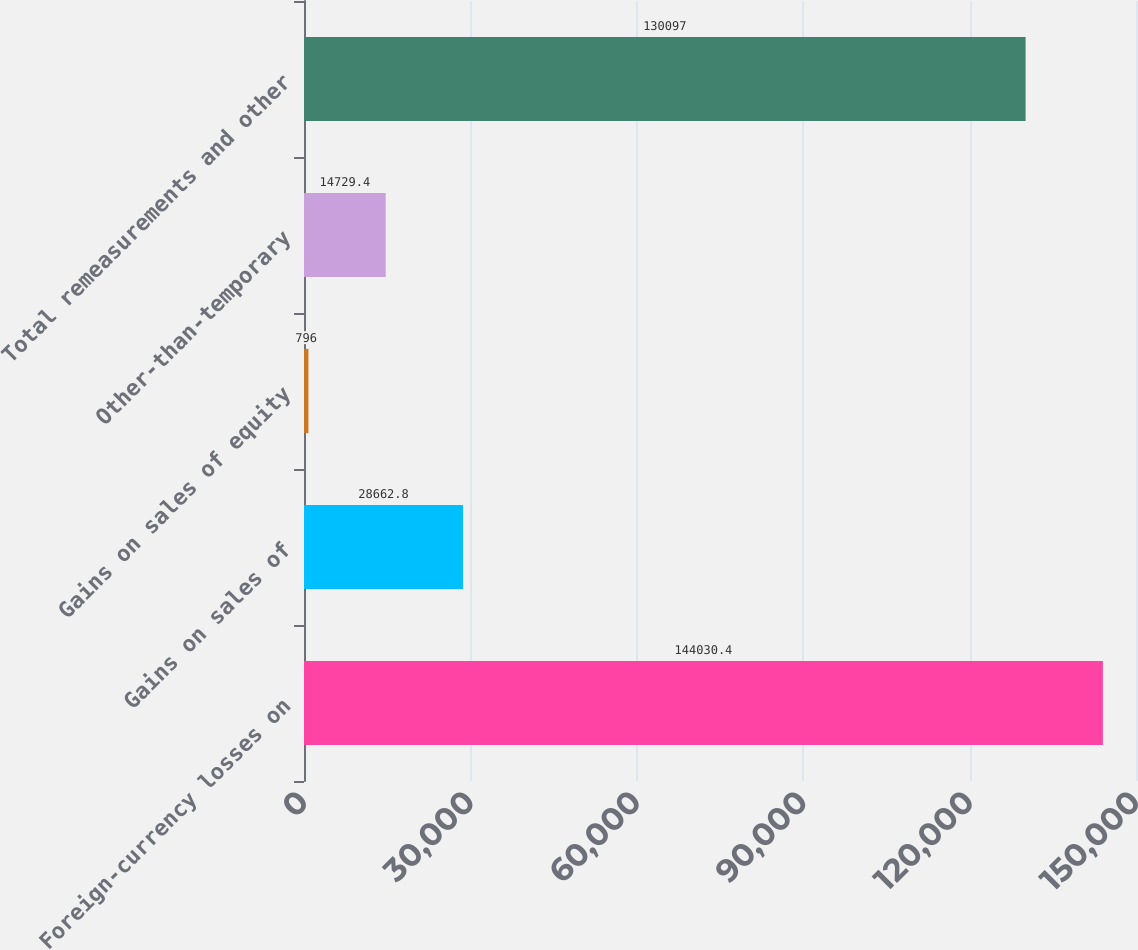Convert chart. <chart><loc_0><loc_0><loc_500><loc_500><bar_chart><fcel>Foreign-currency losses on<fcel>Gains on sales of<fcel>Gains on sales of equity<fcel>Other-than-temporary<fcel>Total remeasurements and other<nl><fcel>144030<fcel>28662.8<fcel>796<fcel>14729.4<fcel>130097<nl></chart> 